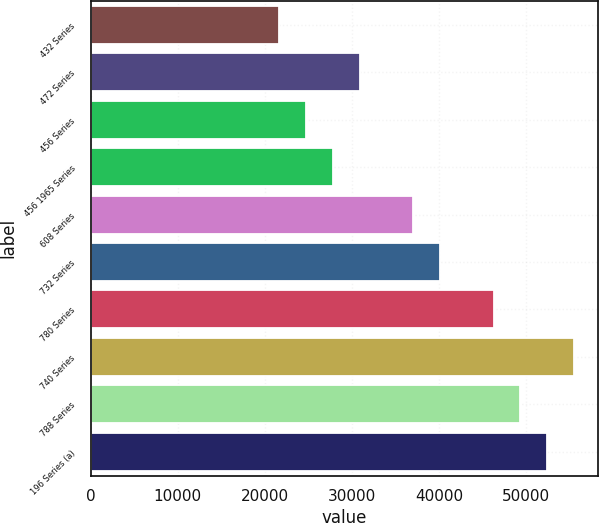Convert chart. <chart><loc_0><loc_0><loc_500><loc_500><bar_chart><fcel>432 Series<fcel>472 Series<fcel>456 Series<fcel>456 1965 Series<fcel>608 Series<fcel>732 Series<fcel>780 Series<fcel>740 Series<fcel>788 Series<fcel>196 Series (a)<nl><fcel>21667.9<fcel>30883<fcel>24739.6<fcel>27811.3<fcel>37026.4<fcel>40098.1<fcel>46241.5<fcel>55456.6<fcel>49313.2<fcel>52384.9<nl></chart> 